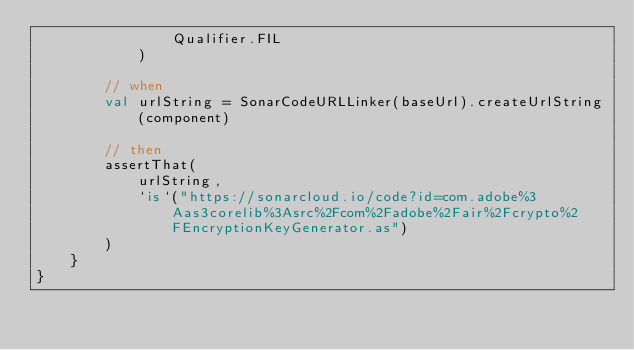<code> <loc_0><loc_0><loc_500><loc_500><_Kotlin_>                Qualifier.FIL
            )

        // when
        val urlString = SonarCodeURLLinker(baseUrl).createUrlString(component)

        // then
        assertThat(
            urlString,
            `is`("https://sonarcloud.io/code?id=com.adobe%3Aas3corelib%3Asrc%2Fcom%2Fadobe%2Fair%2Fcrypto%2FEncryptionKeyGenerator.as")
        )
    }
}
</code> 